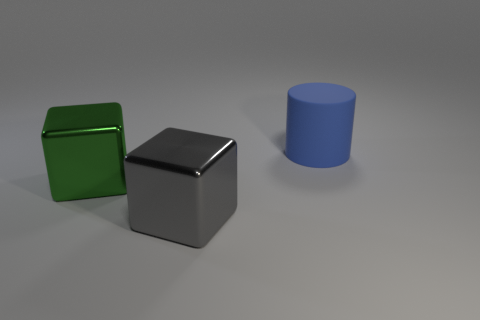Is the number of cubes that are to the left of the green metallic block less than the number of big cubes to the right of the cylinder? In the image, there is one green cube to the left and one silver cube to the right of the blue cylinder. Since there's an equal number of cubes on both sides, the answer would be no; the number of cubes to the left of the green metallic block is not less than the number of big cubes to the right of the cylinder, because there is one cube in each specified location. 